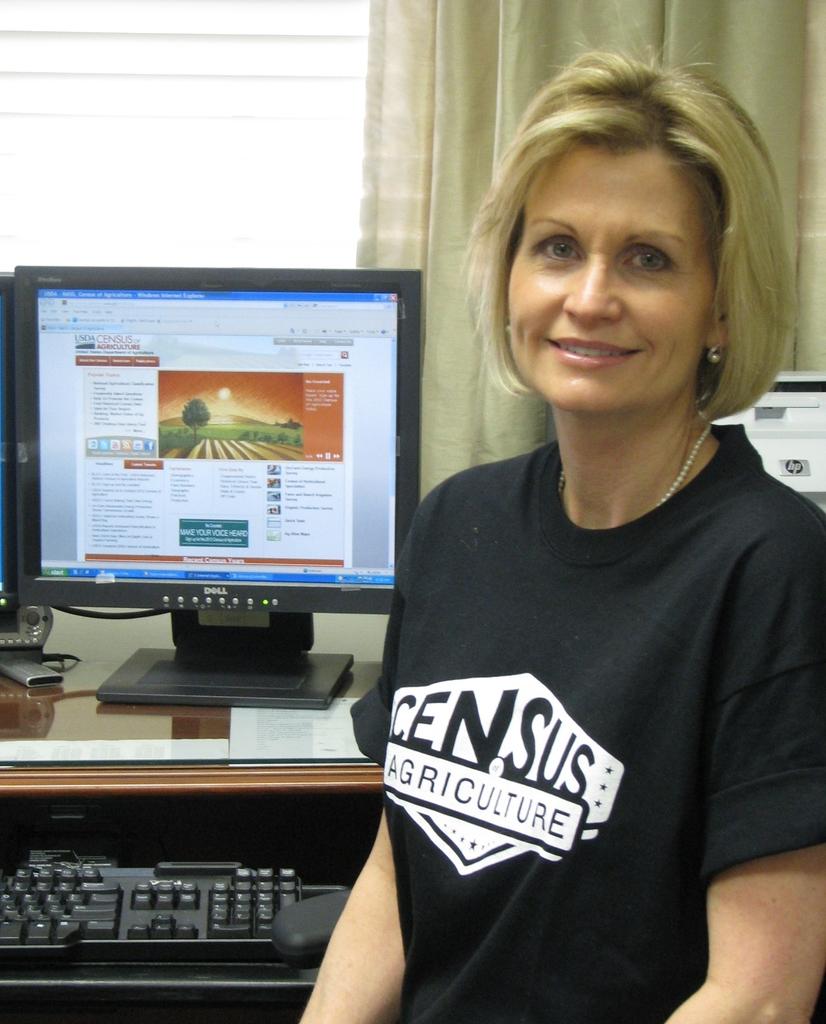What does her shirt say?
Provide a succinct answer. Census agriculture. What class in shown on the ladies shirt?
Offer a very short reply. Agriculture. 